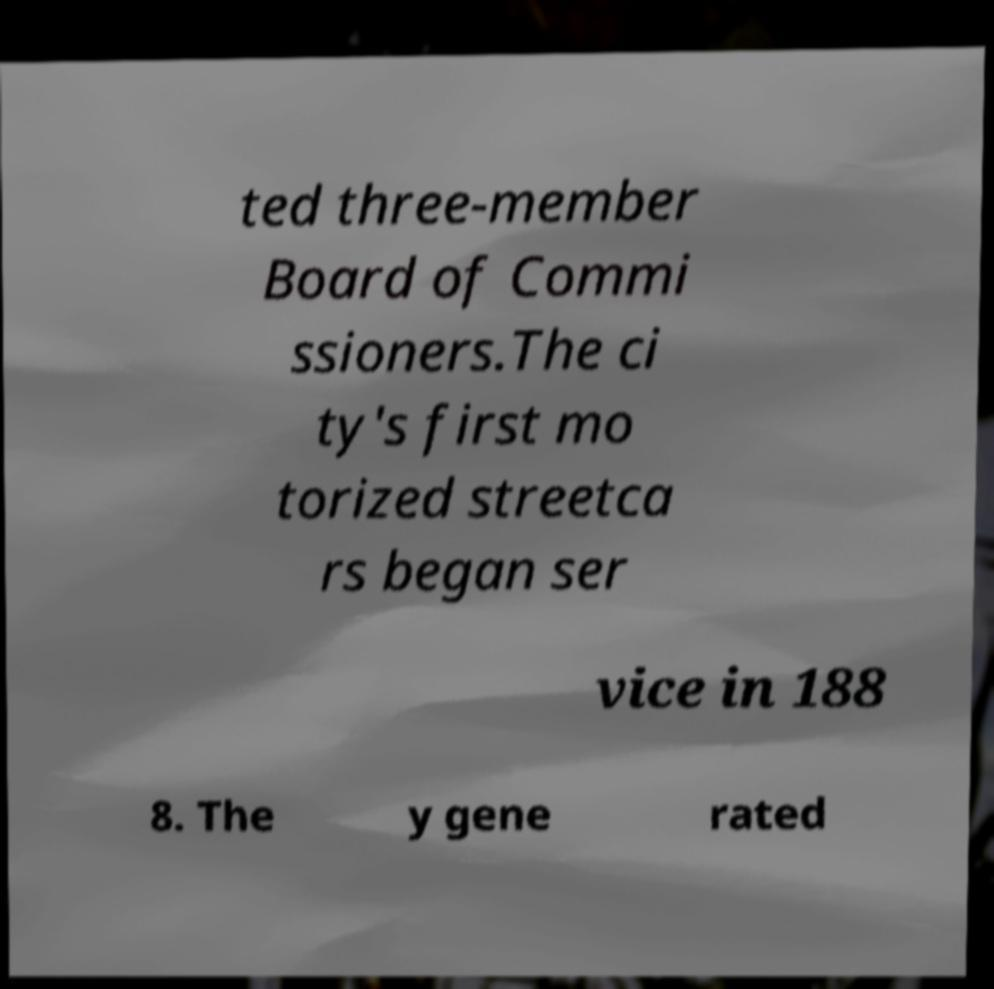Can you accurately transcribe the text from the provided image for me? ted three-member Board of Commi ssioners.The ci ty's first mo torized streetca rs began ser vice in 188 8. The y gene rated 